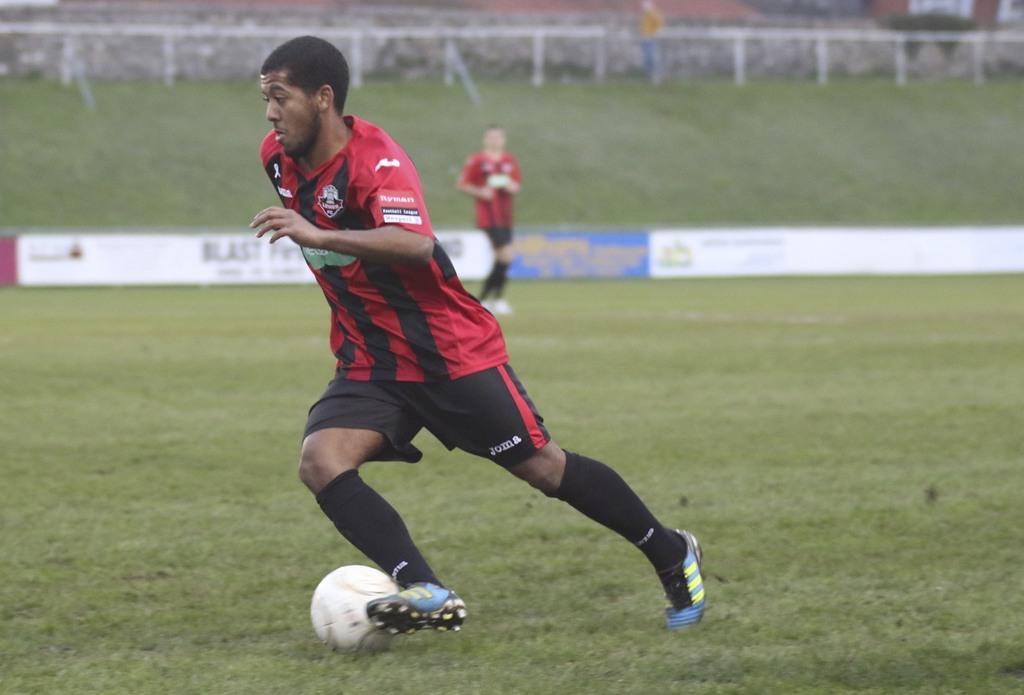In one or two sentences, can you explain what this image depicts? In the image there is a man,he is playing football and he is running and hitting the ball with his leg, behind the man another player is standing on the ground and around the ground there is a fencing of banners. The players are wearing red and black dress. 